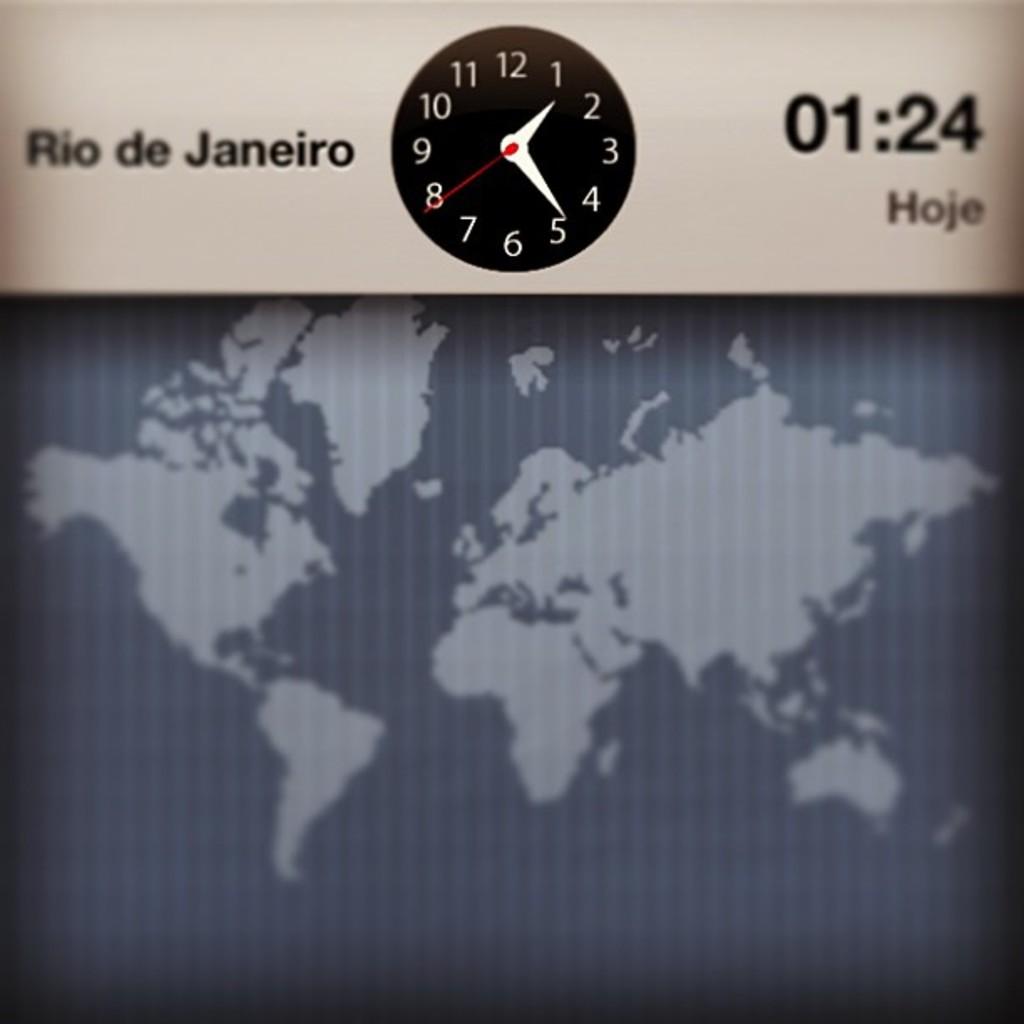In what city is it 01:24?
Offer a very short reply. Rio de janeiro. What time is it?
Your response must be concise. 1:24. 